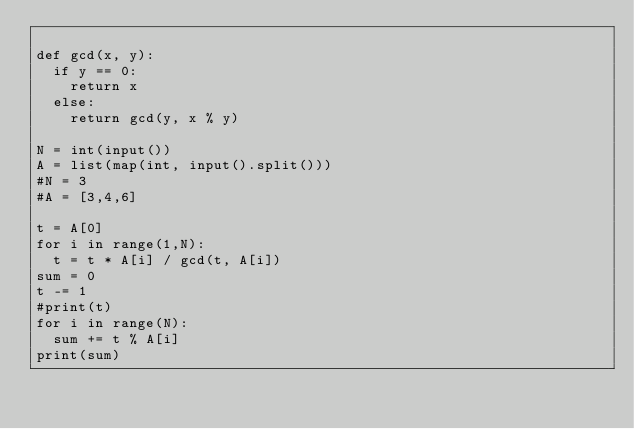<code> <loc_0><loc_0><loc_500><loc_500><_Python_>
def gcd(x, y):
	if y == 0:
		return x
	else:
		return gcd(y, x % y)

N = int(input())
A = list(map(int, input().split()))
#N = 3
#A = [3,4,6]

t = A[0]
for i in range(1,N):
	t = t * A[i] / gcd(t, A[i])
sum = 0
t -= 1
#print(t)
for i in range(N):
	sum += t % A[i]
print(sum)
</code> 